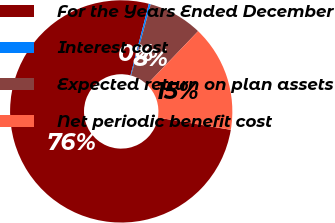Convert chart. <chart><loc_0><loc_0><loc_500><loc_500><pie_chart><fcel>For the Years Ended December<fcel>Interest cost<fcel>Expected return on plan assets<fcel>Net periodic benefit cost<nl><fcel>76.35%<fcel>0.28%<fcel>7.88%<fcel>15.49%<nl></chart> 